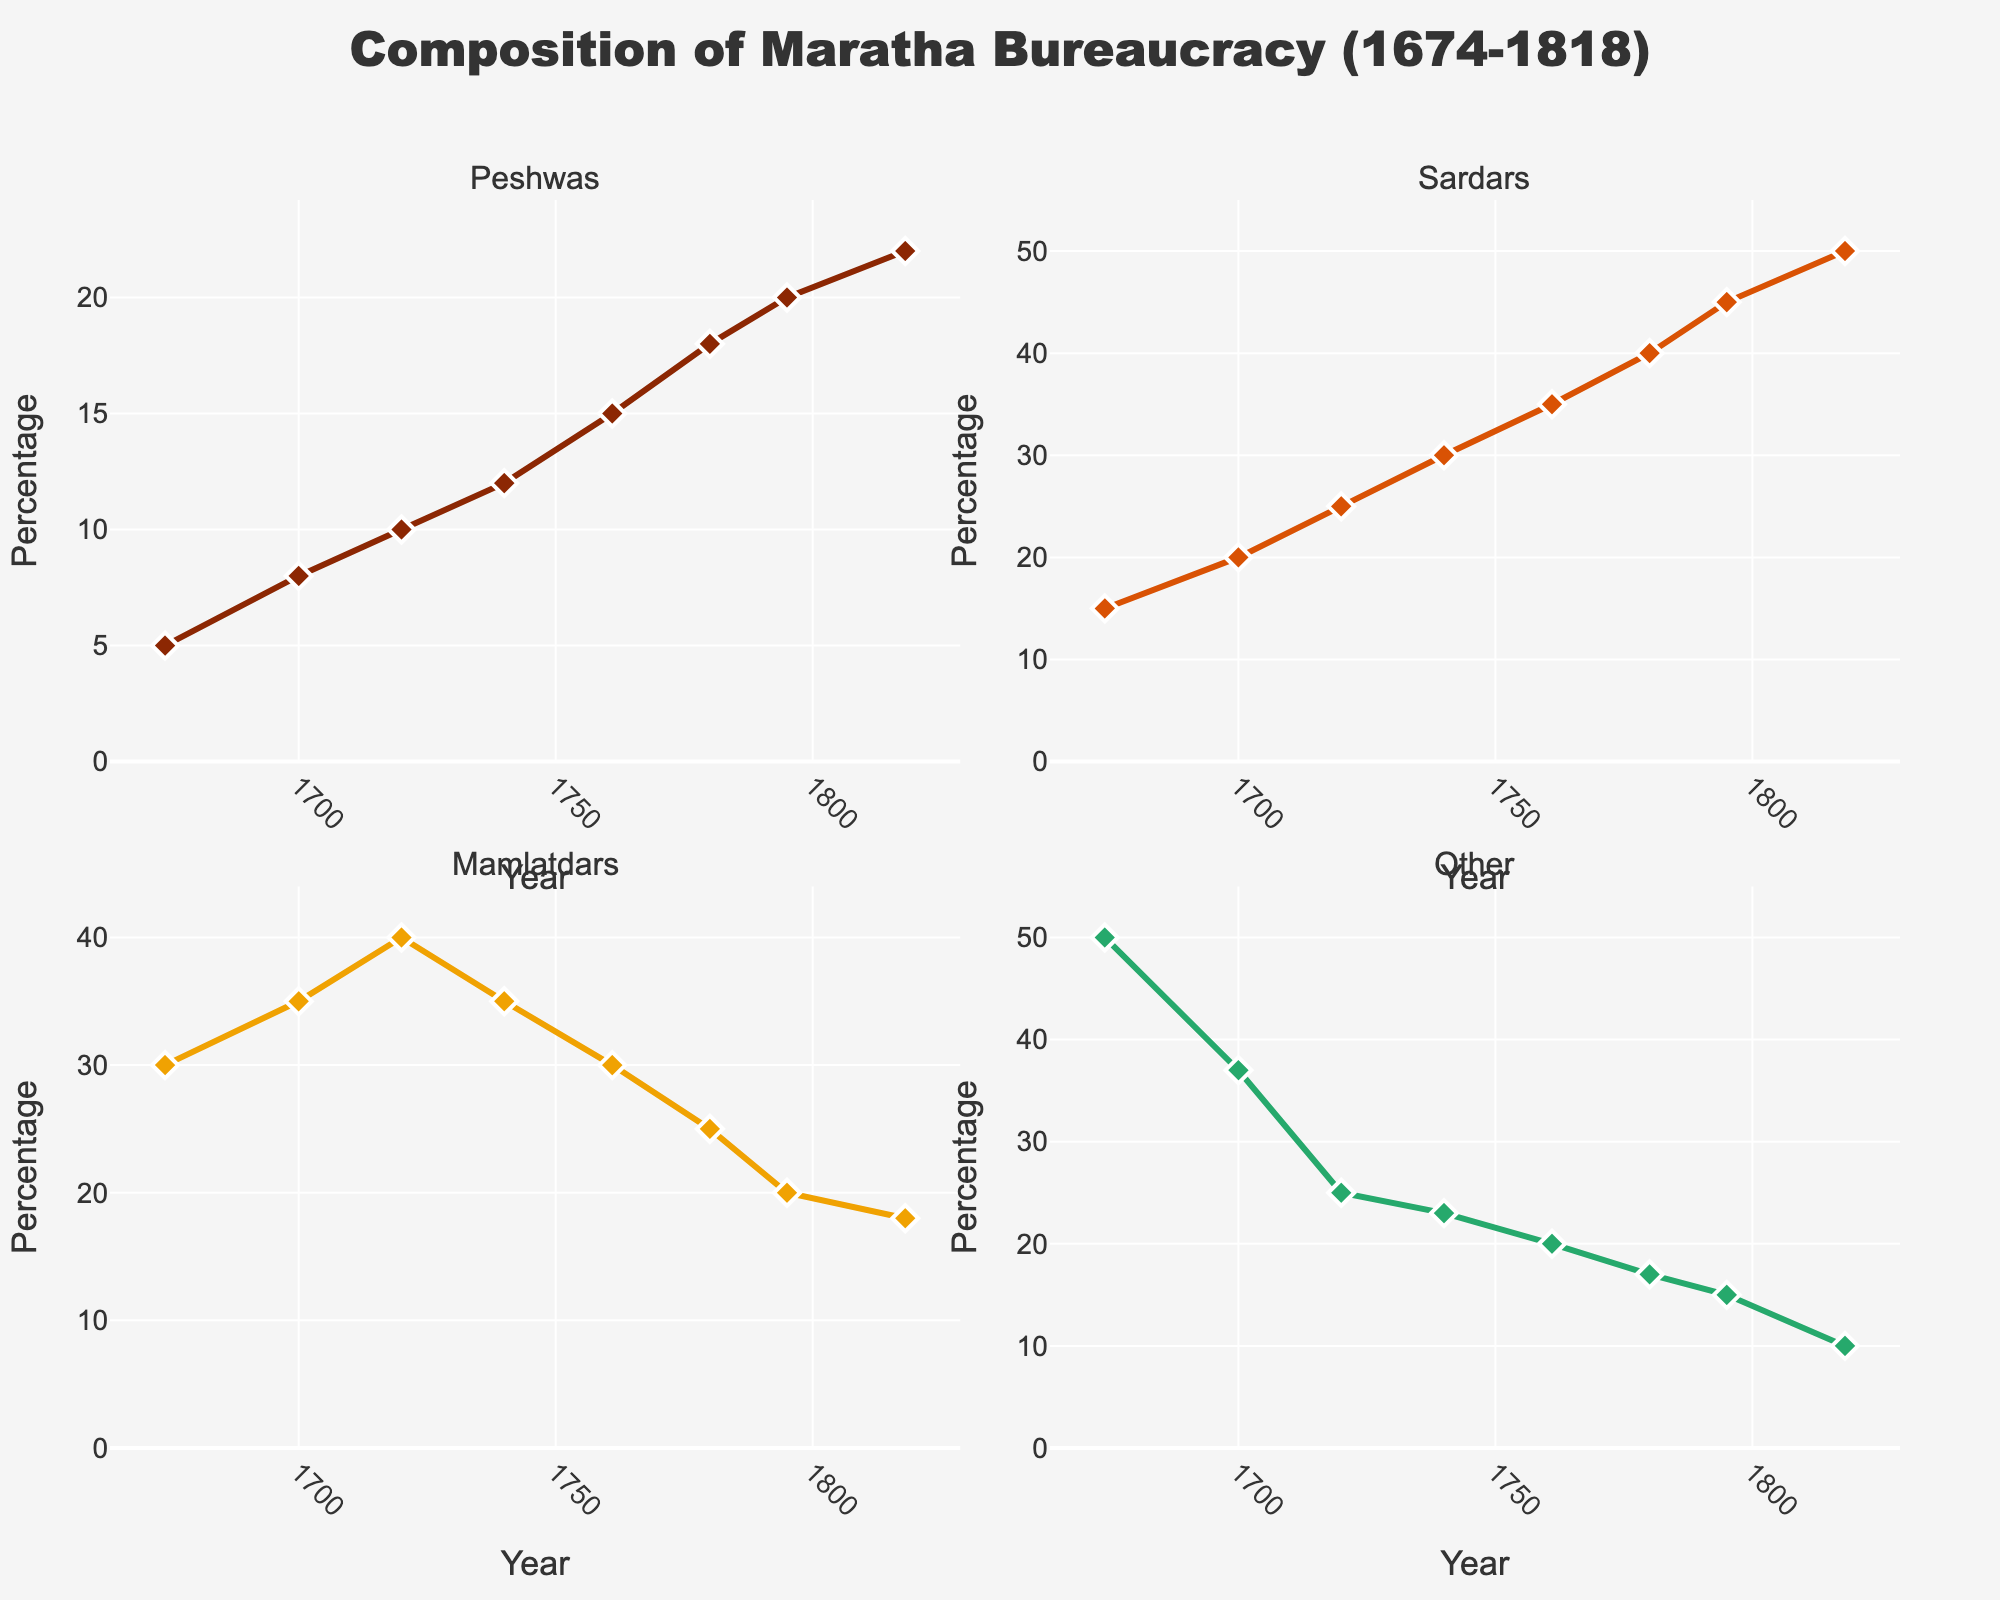What year had the highest percentage of Peshwas? In the subplot for Peshwas, the highest point on the line corresponds to the year on the x-axis which is 1818.
Answer: 1818 Which administrative role saw the largest increase in proportion from 1674 to 1818? Calculate the difference for each role between 1674 and 1818: Peshwas (22-5=17), Sardars (50-15=35), Mamlatdars (18-30=-12), and Other (10-50=-40). The Sardars had the largest positive increase.
Answer: Sardars By how much did the percentage of Mamlatdars decline between 1720 and 1795? Refer to the subplot for Mamlatdars, subtract the values: 40 (1720) - 20 (1795) = 20.
Answer: 20 Which role had the most stable (least fluctuating) percentage over the years? By visually comparing the smoothness of the lines in each subplot, "Other" has the least variance.
Answer: Other At which year do the Sardars and Mamlatdars percentages diverge the most? Calculate the difference between Sardars and Mamlatdars for each year and identify the year with the highest difference. In 1795, Sardars (45) and Mamlatdars (20) differ the most by 25.
Answer: 1795 What can be inferred about the trend of Peshwas and Mamlatdars' percentages over time? Both subplots show an increasing trend for Peshwas and a decreasing trend for Mamlatdars across the years.
Answer: Peshwas increased, Mamlatdars decreased Which two roles had a continuous increase in their proportions over time? By checking individual subplots, only Peshwas and Sardars show a continuous upward trend in their lines.
Answer: Peshwas, Sardars What percentage did "Other" occupy in the year 1761? Look at the subplot for Other and locate the y-coordinate for the year 1761, which is 20.
Answer: 20 Which role had the highest percentage in the start year 1674? Compare the values of each role in 1674, Other had the highest proportion at 50.
Answer: Other By how much did the percentage of "Other" change from 1761 to 1818? Calculate the difference of "Other" between the two years: 10 (1818) - 20 (1761) = -10.
Answer: -10 